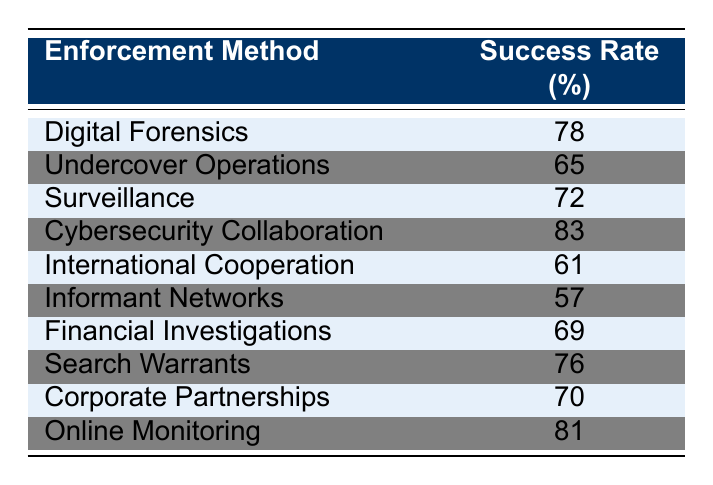What is the success rate of Cybersecurity Collaboration? The table lists the success rate for each enforcement method. Looking at the row for "Cybersecurity Collaboration," it states the success rate is 83%.
Answer: 83% Which enforcement method has the highest success rate? By examining the success rates listed in the table, "Cybersecurity Collaboration" has the highest success rate at 83%.
Answer: Cybersecurity Collaboration What is the average success rate of the enforcement methods listed? To calculate the average, sum all the success rates: 78 + 65 + 72 + 83 + 61 + 57 + 69 + 76 + 70 + 81 = 761. There are 10 methods, so divide by 10: 761 / 10 = 76.1.
Answer: 76.1 Is the success rate of Informant Networks higher than that of Financial Investigations? The success rate for Informant Networks is 57%, while for Financial Investigations it is 69%. Since 57% is less than 69%, the statement is false.
Answer: No What is the difference in success rates between Online Monitoring and International Cooperation? The success rate for Online Monitoring is 81% and for International Cooperation is 61%. To find the difference: 81 - 61 = 20.
Answer: 20 Which two enforcement methods have success rates lower than 70%? By reviewing the table, "Informant Networks" (57%) and "International Cooperation" (61%) are both below 70%. Therefore, these two methods meet the criteria.
Answer: Informant Networks, International Cooperation How many enforcement methods have success rates higher than 75%? The enforcement methods with rates higher than 75% are "Digital Forensics" (78%), "Cybersecurity Collaboration" (83%), "Search Warrants" (76%), and "Online Monitoring" (81%). Counting them gives us 4 methods.
Answer: 4 Are there any enforcement methods with success rates less than 60%? Reviewing the table, "Informant Networks" (57%) is the only method below 60%. Therefore, the statement is true.
Answer: Yes What is the success rate of Search Warrants compared to Corporate Partnerships? "Search Warrants" has a success rate of 76%, and "Corporate Partnerships" has 70%. Since 76% is greater than 70%, Search Warrants has a higher success rate.
Answer: Higher 